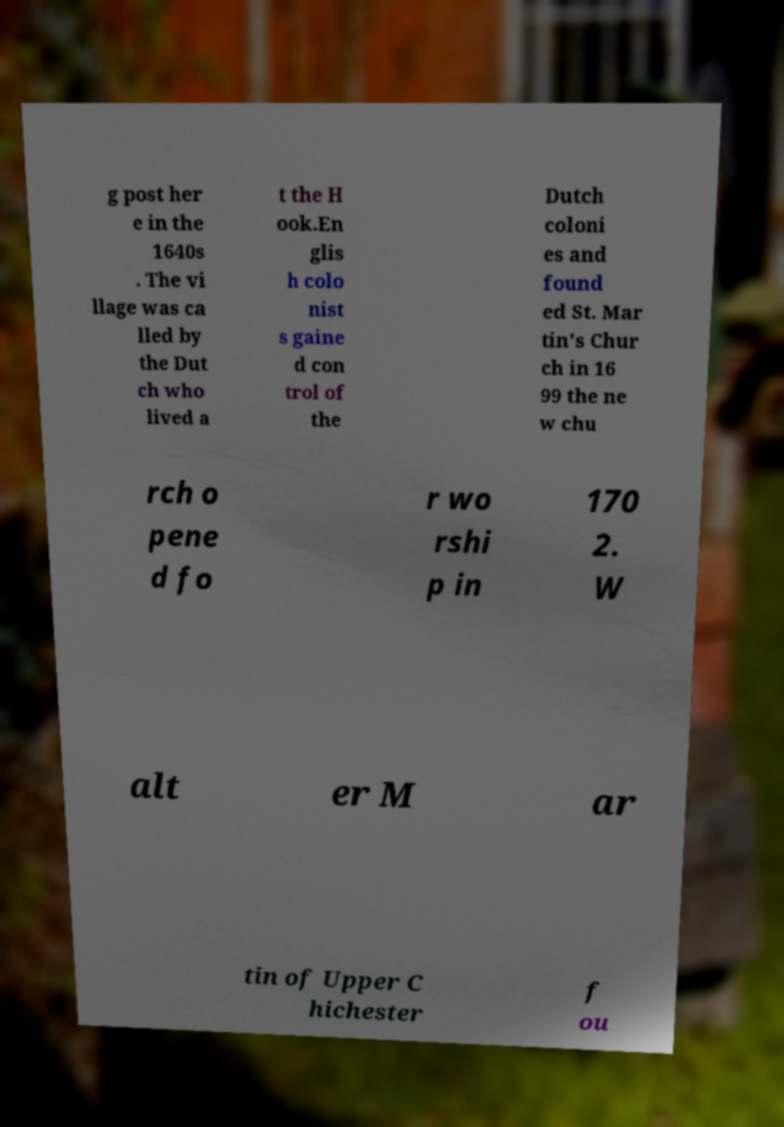Please identify and transcribe the text found in this image. g post her e in the 1640s . The vi llage was ca lled by the Dut ch who lived a t the H ook.En glis h colo nist s gaine d con trol of the Dutch coloni es and found ed St. Mar tin's Chur ch in 16 99 the ne w chu rch o pene d fo r wo rshi p in 170 2. W alt er M ar tin of Upper C hichester f ou 